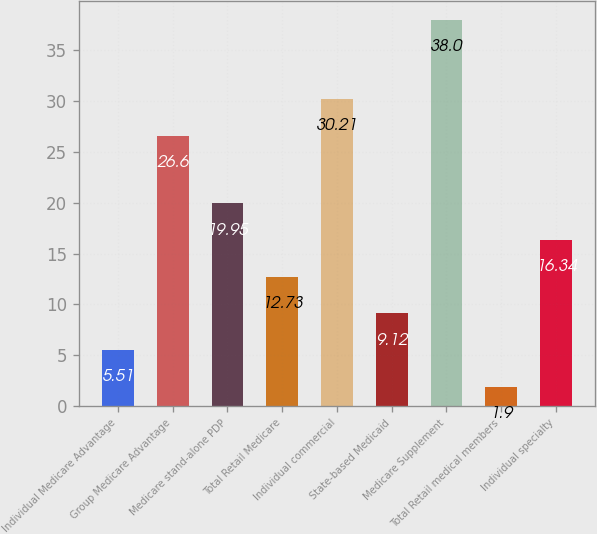Convert chart. <chart><loc_0><loc_0><loc_500><loc_500><bar_chart><fcel>Individual Medicare Advantage<fcel>Group Medicare Advantage<fcel>Medicare stand-alone PDP<fcel>Total Retail Medicare<fcel>Individual commercial<fcel>State-based Medicaid<fcel>Medicare Supplement<fcel>Total Retail medical members<fcel>Individual specialty<nl><fcel>5.51<fcel>26.6<fcel>19.95<fcel>12.73<fcel>30.21<fcel>9.12<fcel>38<fcel>1.9<fcel>16.34<nl></chart> 